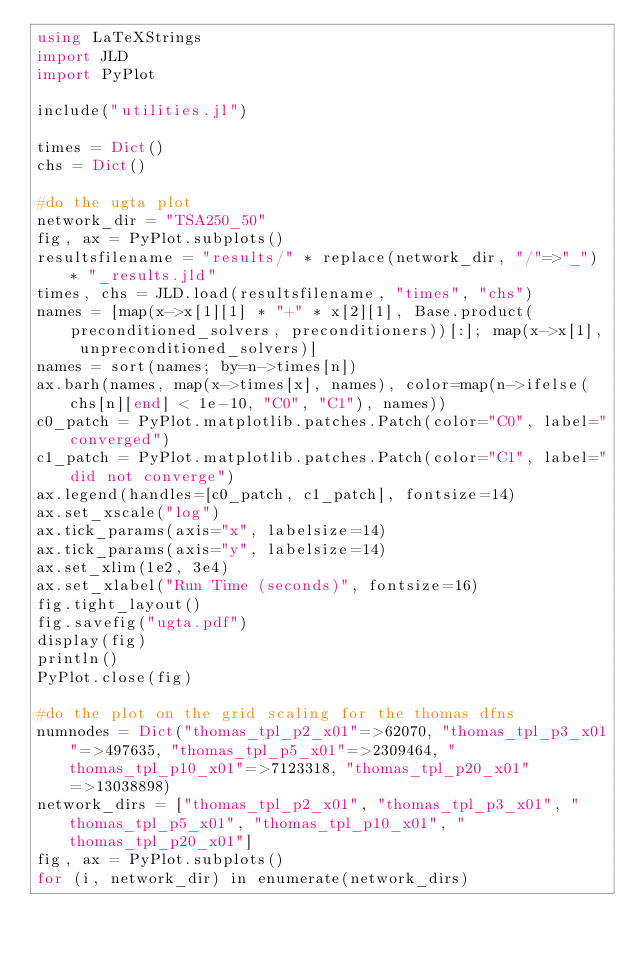Convert code to text. <code><loc_0><loc_0><loc_500><loc_500><_Julia_>using LaTeXStrings
import JLD
import PyPlot

include("utilities.jl")

times = Dict()
chs = Dict()

#do the ugta plot
network_dir = "TSA250_50"
fig, ax = PyPlot.subplots()
resultsfilename = "results/" * replace(network_dir, "/"=>"_") * "_results.jld"
times, chs = JLD.load(resultsfilename, "times", "chs")
names = [map(x->x[1][1] * "+" * x[2][1], Base.product(preconditioned_solvers, preconditioners))[:]; map(x->x[1], unpreconditioned_solvers)]
names = sort(names; by=n->times[n])
ax.barh(names, map(x->times[x], names), color=map(n->ifelse(chs[n][end] < 1e-10, "C0", "C1"), names))
c0_patch = PyPlot.matplotlib.patches.Patch(color="C0", label="converged")
c1_patch = PyPlot.matplotlib.patches.Patch(color="C1", label="did not converge")
ax.legend(handles=[c0_patch, c1_patch], fontsize=14)
ax.set_xscale("log")
ax.tick_params(axis="x", labelsize=14)
ax.tick_params(axis="y", labelsize=14)
ax.set_xlim(1e2, 3e4)
ax.set_xlabel("Run Time (seconds)", fontsize=16)
fig.tight_layout()
fig.savefig("ugta.pdf")
display(fig)
println()
PyPlot.close(fig)

#do the plot on the grid scaling for the thomas dfns
numnodes = Dict("thomas_tpl_p2_x01"=>62070, "thomas_tpl_p3_x01"=>497635, "thomas_tpl_p5_x01"=>2309464, "thomas_tpl_p10_x01"=>7123318, "thomas_tpl_p20_x01"=>13038898)
network_dirs = ["thomas_tpl_p2_x01", "thomas_tpl_p3_x01", "thomas_tpl_p5_x01", "thomas_tpl_p10_x01", "thomas_tpl_p20_x01"]
fig, ax = PyPlot.subplots()
for (i, network_dir) in enumerate(network_dirs)</code> 